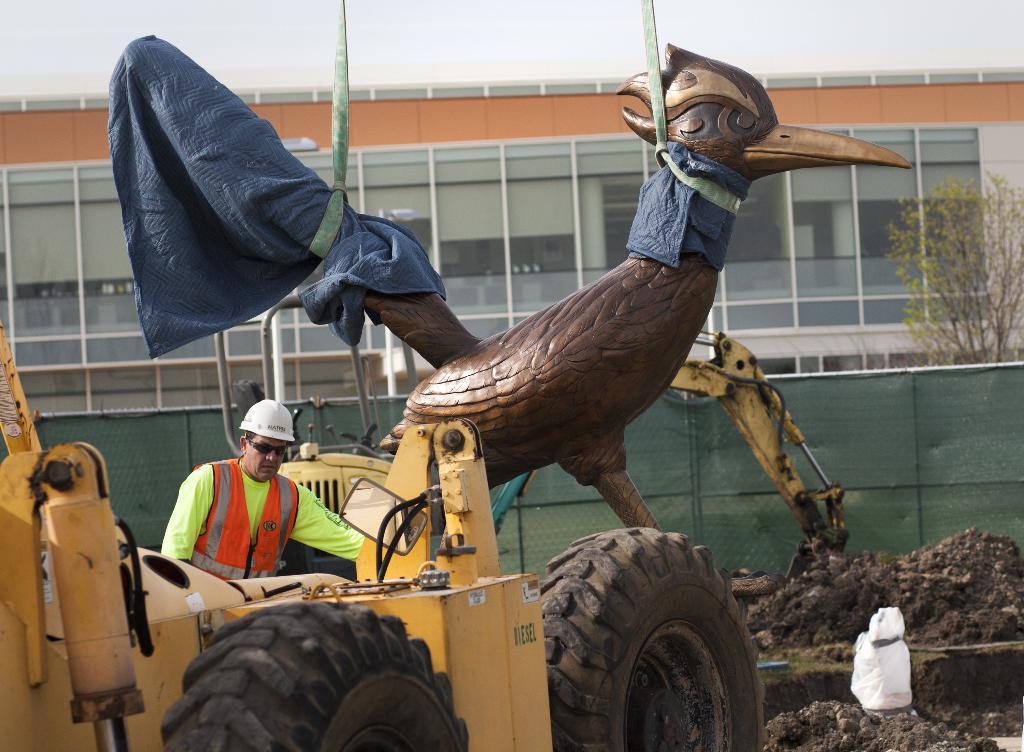Could you give a brief overview of what you see in this image? In this picture I can see a person operating vehicle, I can see sculpture with ropes, behind we can see fencing, trees, buildings. 